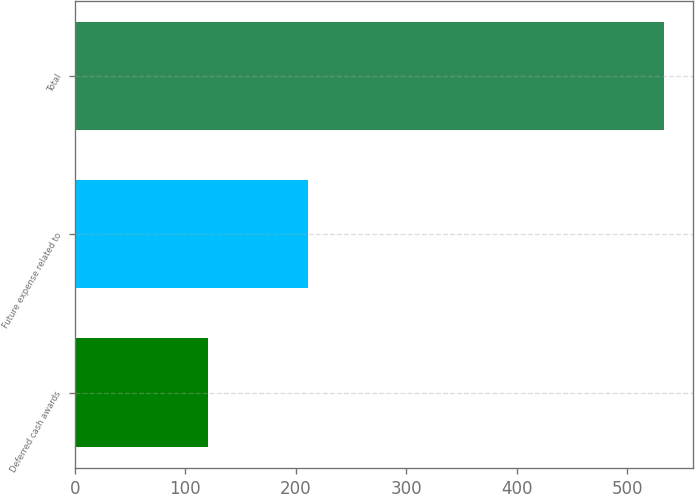Convert chart to OTSL. <chart><loc_0><loc_0><loc_500><loc_500><bar_chart><fcel>Deferred cash awards<fcel>Future expense related to<fcel>Total<nl><fcel>121<fcel>211<fcel>533<nl></chart> 